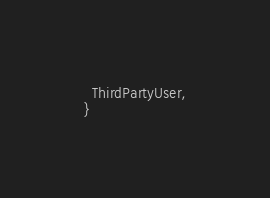Convert code to text. <code><loc_0><loc_0><loc_500><loc_500><_TypeScript_>  ThirdPartyUser,
}
</code> 